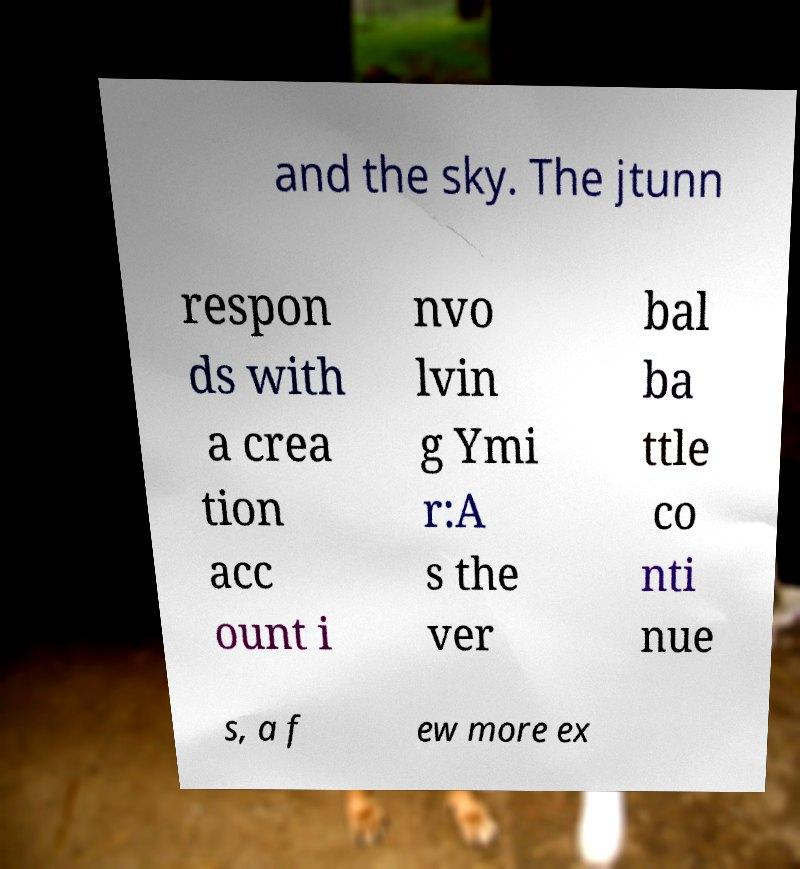Please identify and transcribe the text found in this image. and the sky. The jtunn respon ds with a crea tion acc ount i nvo lvin g Ymi r:A s the ver bal ba ttle co nti nue s, a f ew more ex 